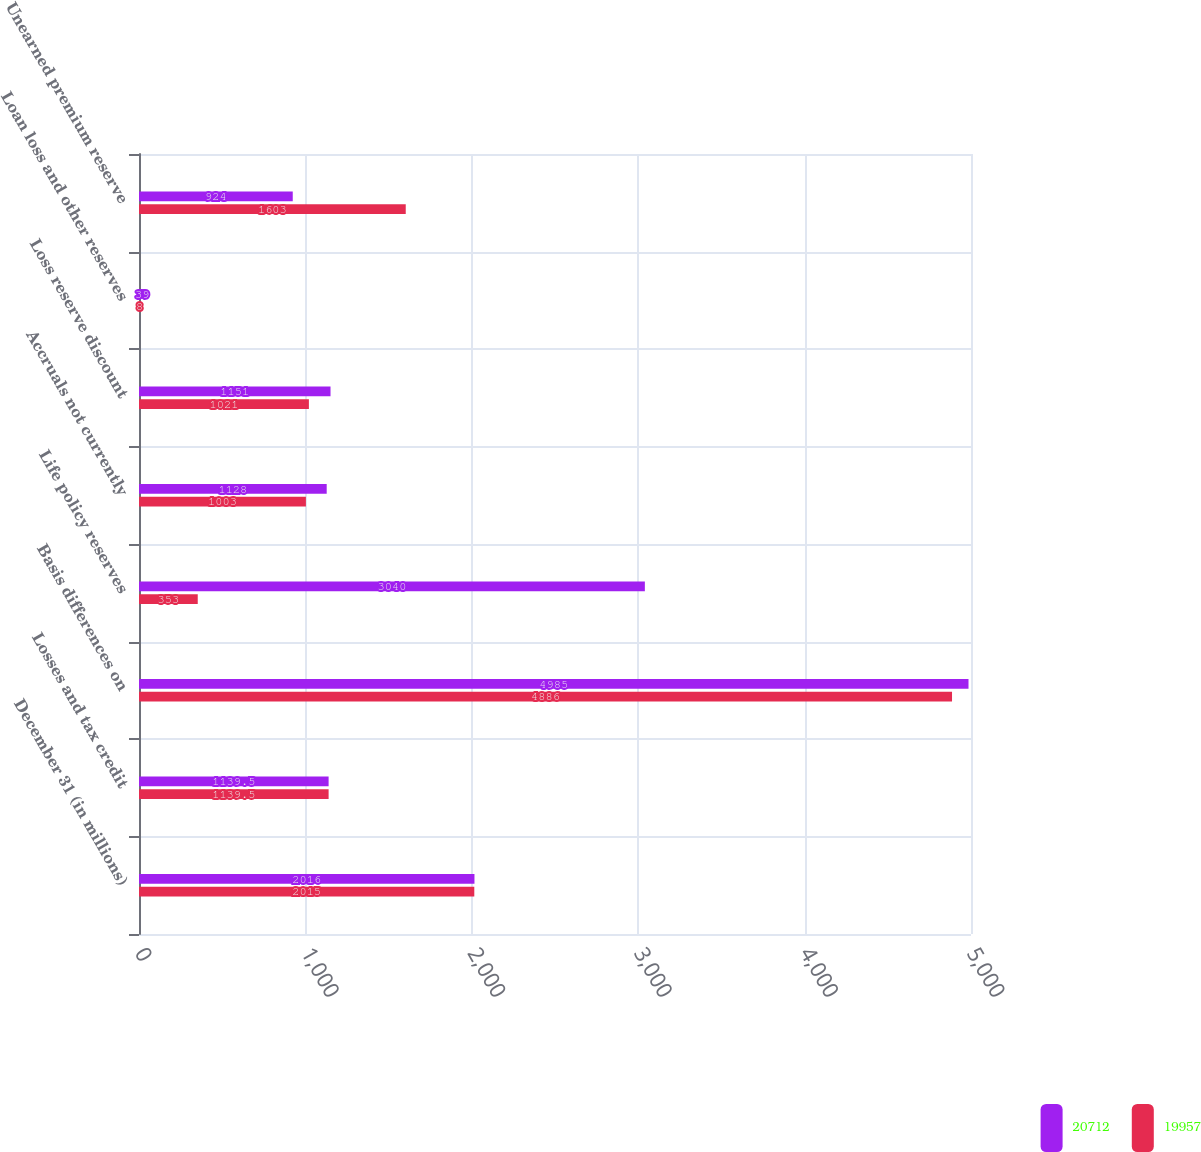<chart> <loc_0><loc_0><loc_500><loc_500><stacked_bar_chart><ecel><fcel>December 31 (in millions)<fcel>Losses and tax credit<fcel>Basis differences on<fcel>Life policy reserves<fcel>Accruals not currently<fcel>Loss reserve discount<fcel>Loan loss and other reserves<fcel>Unearned premium reserve<nl><fcel>20712<fcel>2016<fcel>1139.5<fcel>4985<fcel>3040<fcel>1128<fcel>1151<fcel>39<fcel>924<nl><fcel>19957<fcel>2015<fcel>1139.5<fcel>4886<fcel>353<fcel>1003<fcel>1021<fcel>8<fcel>1603<nl></chart> 